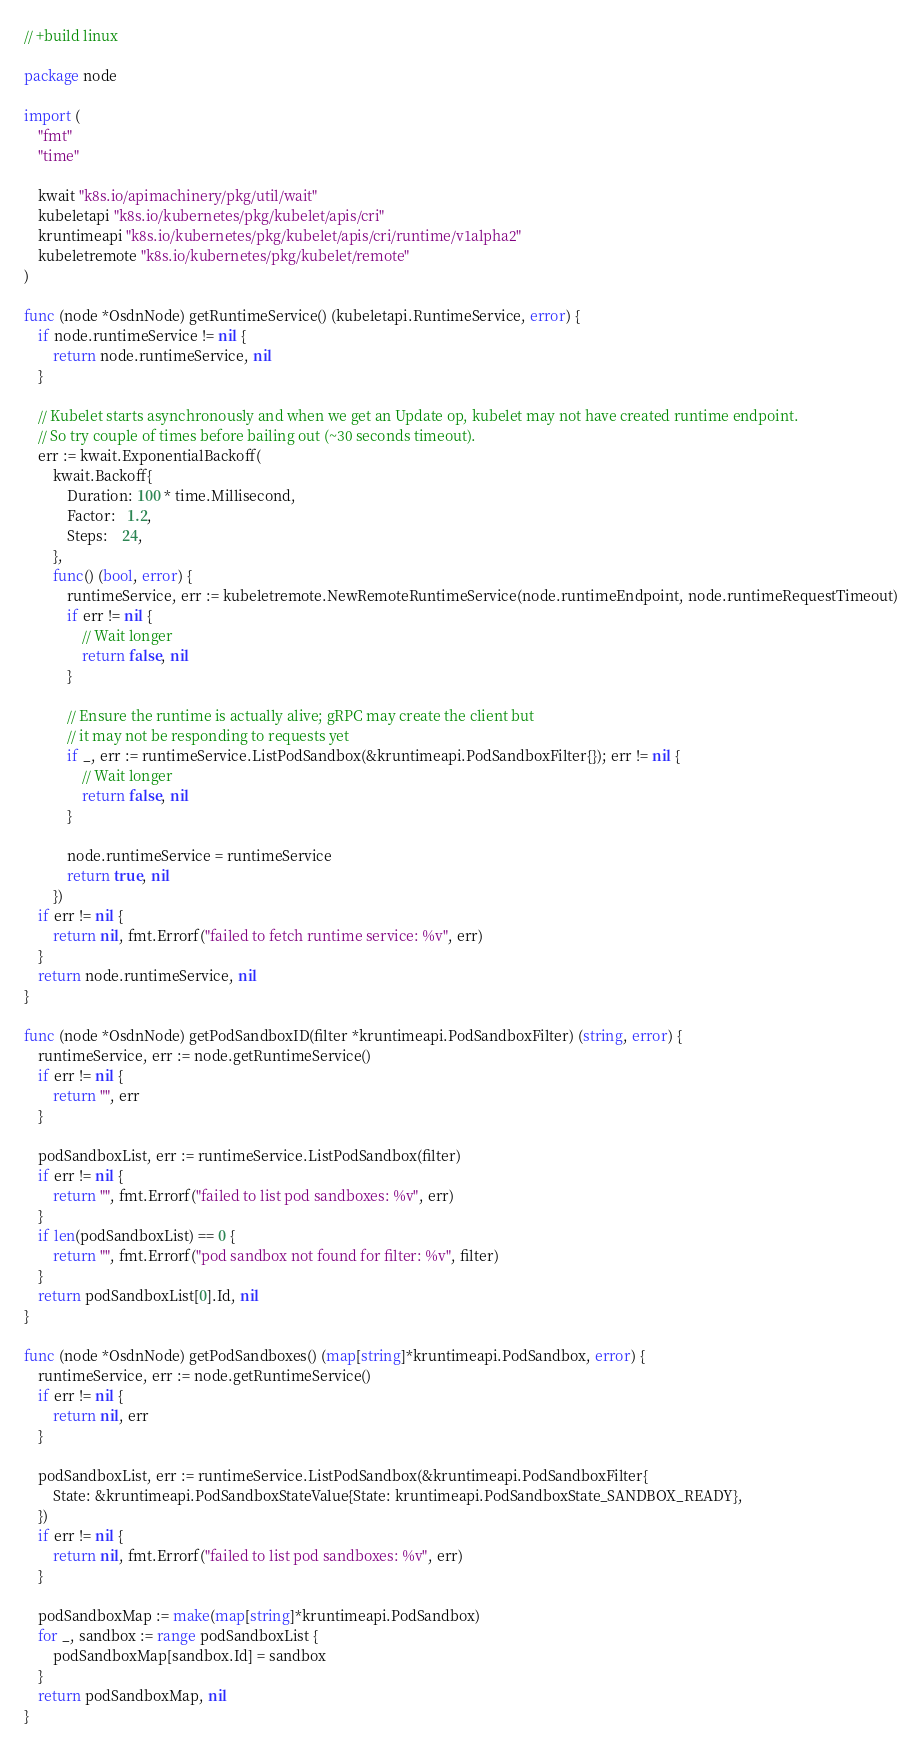Convert code to text. <code><loc_0><loc_0><loc_500><loc_500><_Go_>// +build linux

package node

import (
	"fmt"
	"time"

	kwait "k8s.io/apimachinery/pkg/util/wait"
	kubeletapi "k8s.io/kubernetes/pkg/kubelet/apis/cri"
	kruntimeapi "k8s.io/kubernetes/pkg/kubelet/apis/cri/runtime/v1alpha2"
	kubeletremote "k8s.io/kubernetes/pkg/kubelet/remote"
)

func (node *OsdnNode) getRuntimeService() (kubeletapi.RuntimeService, error) {
	if node.runtimeService != nil {
		return node.runtimeService, nil
	}

	// Kubelet starts asynchronously and when we get an Update op, kubelet may not have created runtime endpoint.
	// So try couple of times before bailing out (~30 seconds timeout).
	err := kwait.ExponentialBackoff(
		kwait.Backoff{
			Duration: 100 * time.Millisecond,
			Factor:   1.2,
			Steps:    24,
		},
		func() (bool, error) {
			runtimeService, err := kubeletremote.NewRemoteRuntimeService(node.runtimeEndpoint, node.runtimeRequestTimeout)
			if err != nil {
				// Wait longer
				return false, nil
			}

			// Ensure the runtime is actually alive; gRPC may create the client but
			// it may not be responding to requests yet
			if _, err := runtimeService.ListPodSandbox(&kruntimeapi.PodSandboxFilter{}); err != nil {
				// Wait longer
				return false, nil
			}

			node.runtimeService = runtimeService
			return true, nil
		})
	if err != nil {
		return nil, fmt.Errorf("failed to fetch runtime service: %v", err)
	}
	return node.runtimeService, nil
}

func (node *OsdnNode) getPodSandboxID(filter *kruntimeapi.PodSandboxFilter) (string, error) {
	runtimeService, err := node.getRuntimeService()
	if err != nil {
		return "", err
	}

	podSandboxList, err := runtimeService.ListPodSandbox(filter)
	if err != nil {
		return "", fmt.Errorf("failed to list pod sandboxes: %v", err)
	}
	if len(podSandboxList) == 0 {
		return "", fmt.Errorf("pod sandbox not found for filter: %v", filter)
	}
	return podSandboxList[0].Id, nil
}

func (node *OsdnNode) getPodSandboxes() (map[string]*kruntimeapi.PodSandbox, error) {
	runtimeService, err := node.getRuntimeService()
	if err != nil {
		return nil, err
	}

	podSandboxList, err := runtimeService.ListPodSandbox(&kruntimeapi.PodSandboxFilter{
		State: &kruntimeapi.PodSandboxStateValue{State: kruntimeapi.PodSandboxState_SANDBOX_READY},
	})
	if err != nil {
		return nil, fmt.Errorf("failed to list pod sandboxes: %v", err)
	}

	podSandboxMap := make(map[string]*kruntimeapi.PodSandbox)
	for _, sandbox := range podSandboxList {
		podSandboxMap[sandbox.Id] = sandbox
	}
	return podSandboxMap, nil
}
</code> 